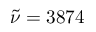<formula> <loc_0><loc_0><loc_500><loc_500>\tilde { \nu } = 3 8 7 4</formula> 